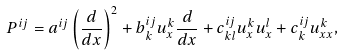<formula> <loc_0><loc_0><loc_500><loc_500>P ^ { i j } = a ^ { i j } \left ( \frac { d } { d x } \right ) ^ { 2 } + b ^ { i j } _ { k } u ^ { k } _ { x } \frac { d } { d x } + c ^ { i j } _ { k l } u ^ { k } _ { x } u ^ { l } _ { x } + c ^ { i j } _ { k } u ^ { k } _ { x x } ,</formula> 